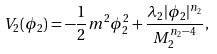<formula> <loc_0><loc_0><loc_500><loc_500>V _ { 2 } ( \phi _ { 2 } ) = - \frac { 1 } { 2 } m ^ { 2 } \phi _ { 2 } ^ { 2 } + \frac { \lambda _ { 2 } | \phi _ { 2 } | ^ { n _ { 2 } } } { M _ { 2 } ^ { n _ { 2 } - 4 } } ,</formula> 